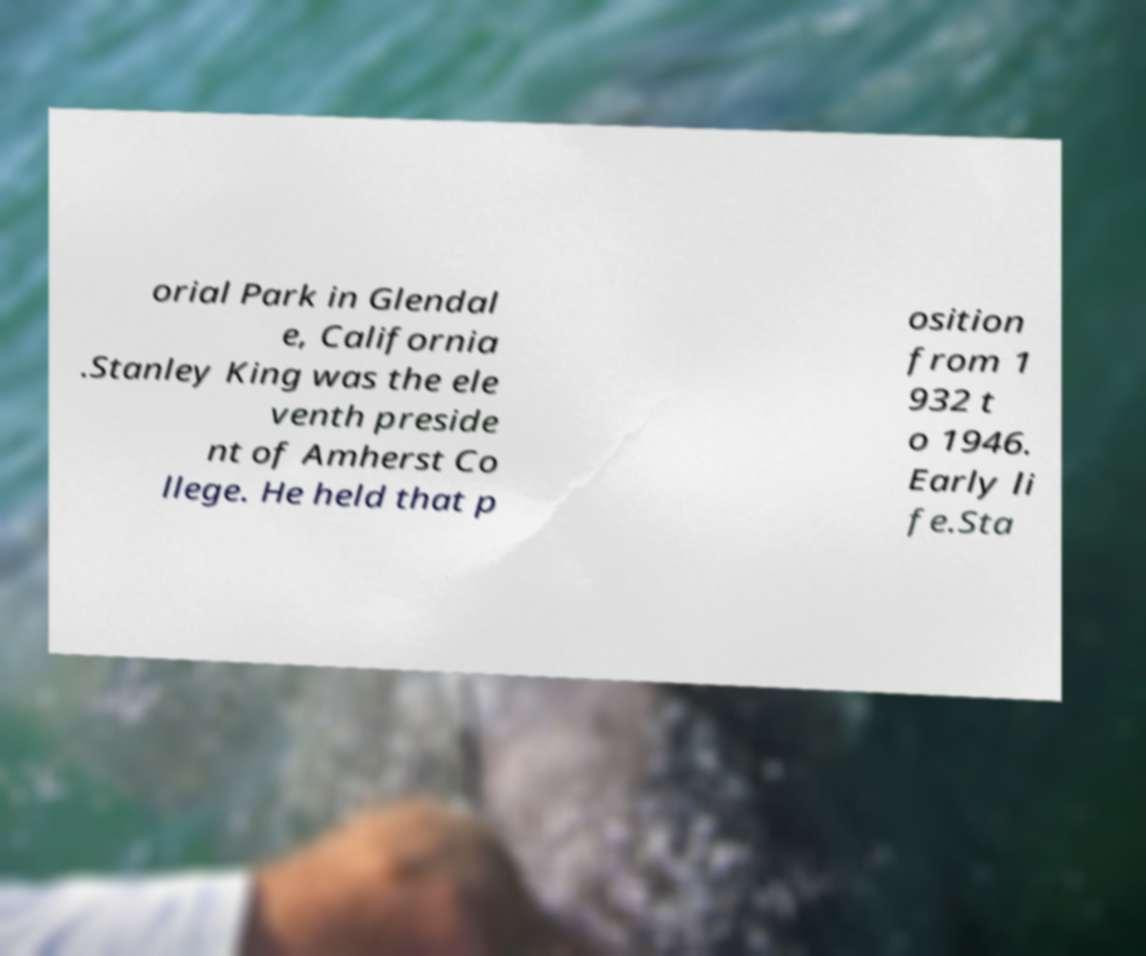For documentation purposes, I need the text within this image transcribed. Could you provide that? orial Park in Glendal e, California .Stanley King was the ele venth preside nt of Amherst Co llege. He held that p osition from 1 932 t o 1946. Early li fe.Sta 